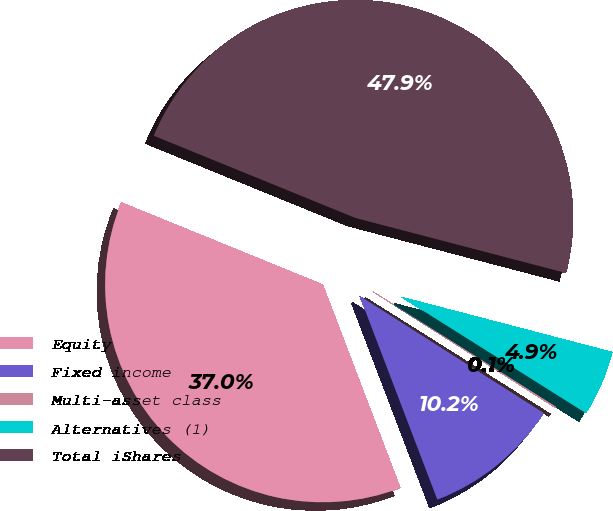<chart> <loc_0><loc_0><loc_500><loc_500><pie_chart><fcel>Equity<fcel>Fixed income<fcel>Multi-asset class<fcel>Alternatives (1)<fcel>Total iShares<nl><fcel>36.96%<fcel>10.18%<fcel>0.08%<fcel>4.87%<fcel>47.91%<nl></chart> 